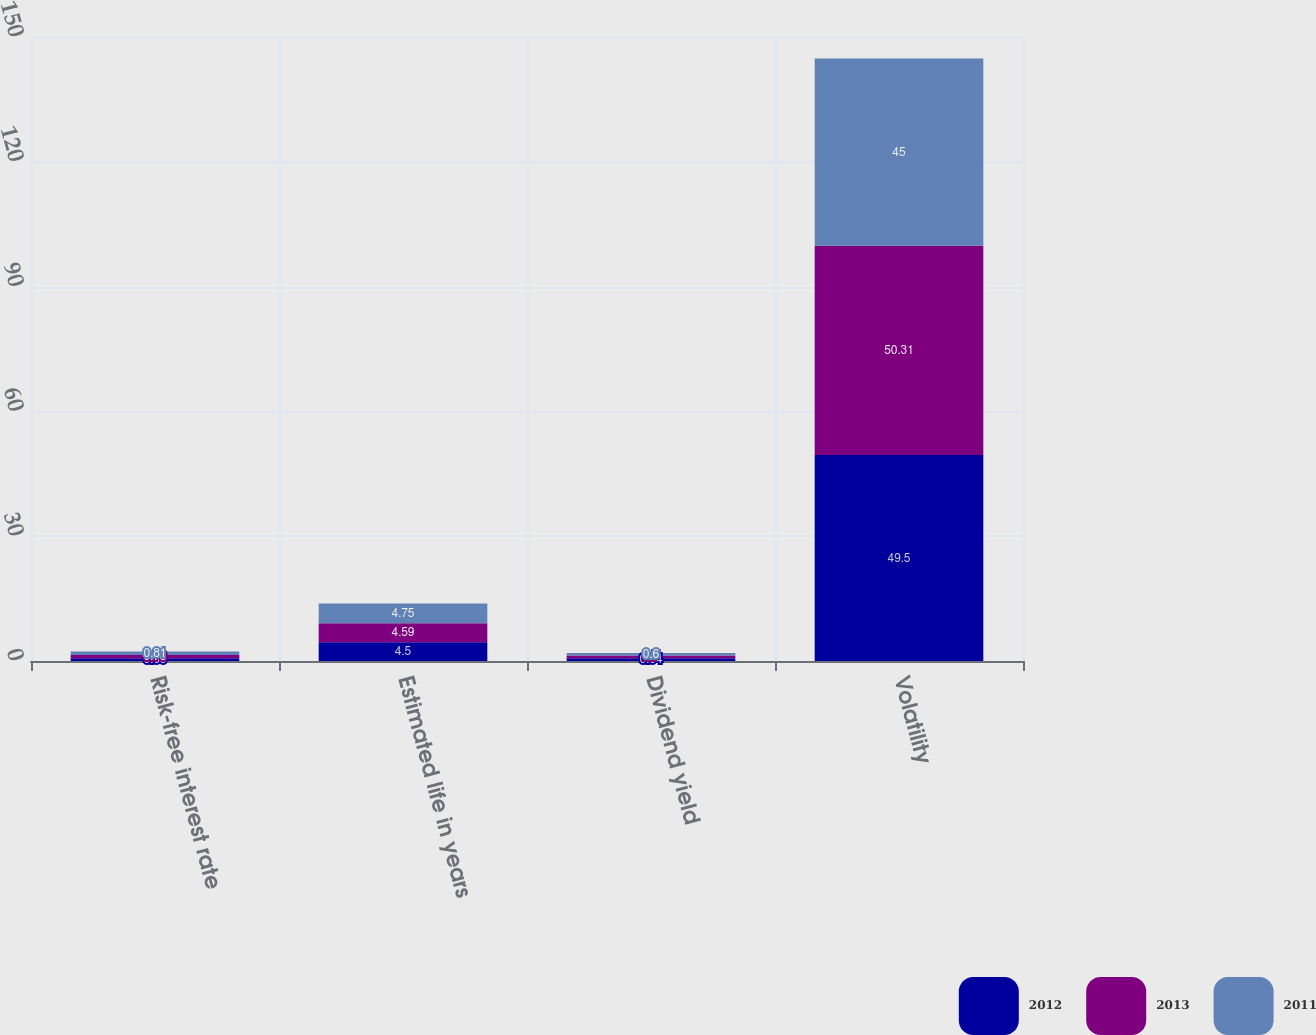Convert chart. <chart><loc_0><loc_0><loc_500><loc_500><stacked_bar_chart><ecel><fcel>Risk-free interest rate<fcel>Estimated life in years<fcel>Dividend yield<fcel>Volatility<nl><fcel>2012<fcel>0.68<fcel>4.5<fcel>0.64<fcel>49.5<nl><fcel>2013<fcel>0.78<fcel>4.59<fcel>0.7<fcel>50.31<nl><fcel>2011<fcel>0.81<fcel>4.75<fcel>0.6<fcel>45<nl></chart> 